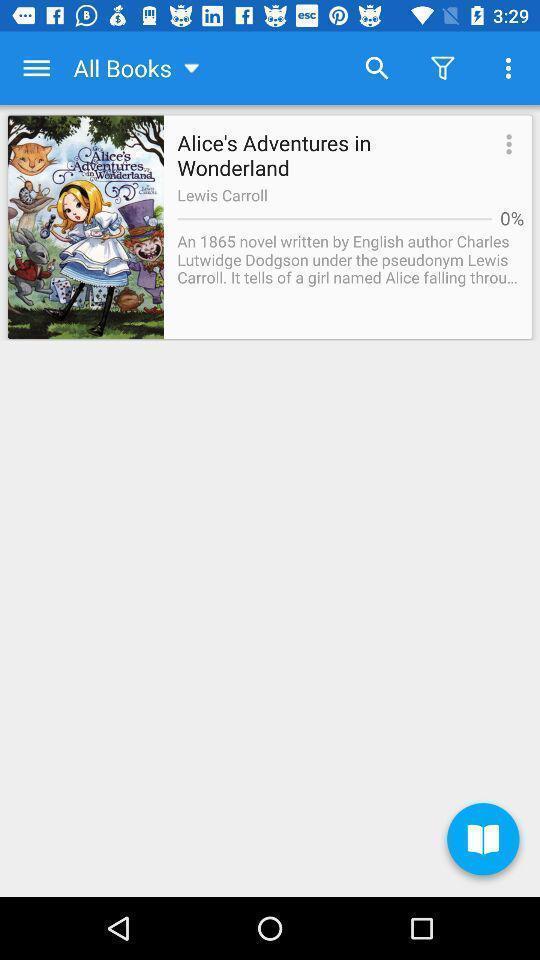What details can you identify in this image? Screen displaying a novel with search and filter buttons. 